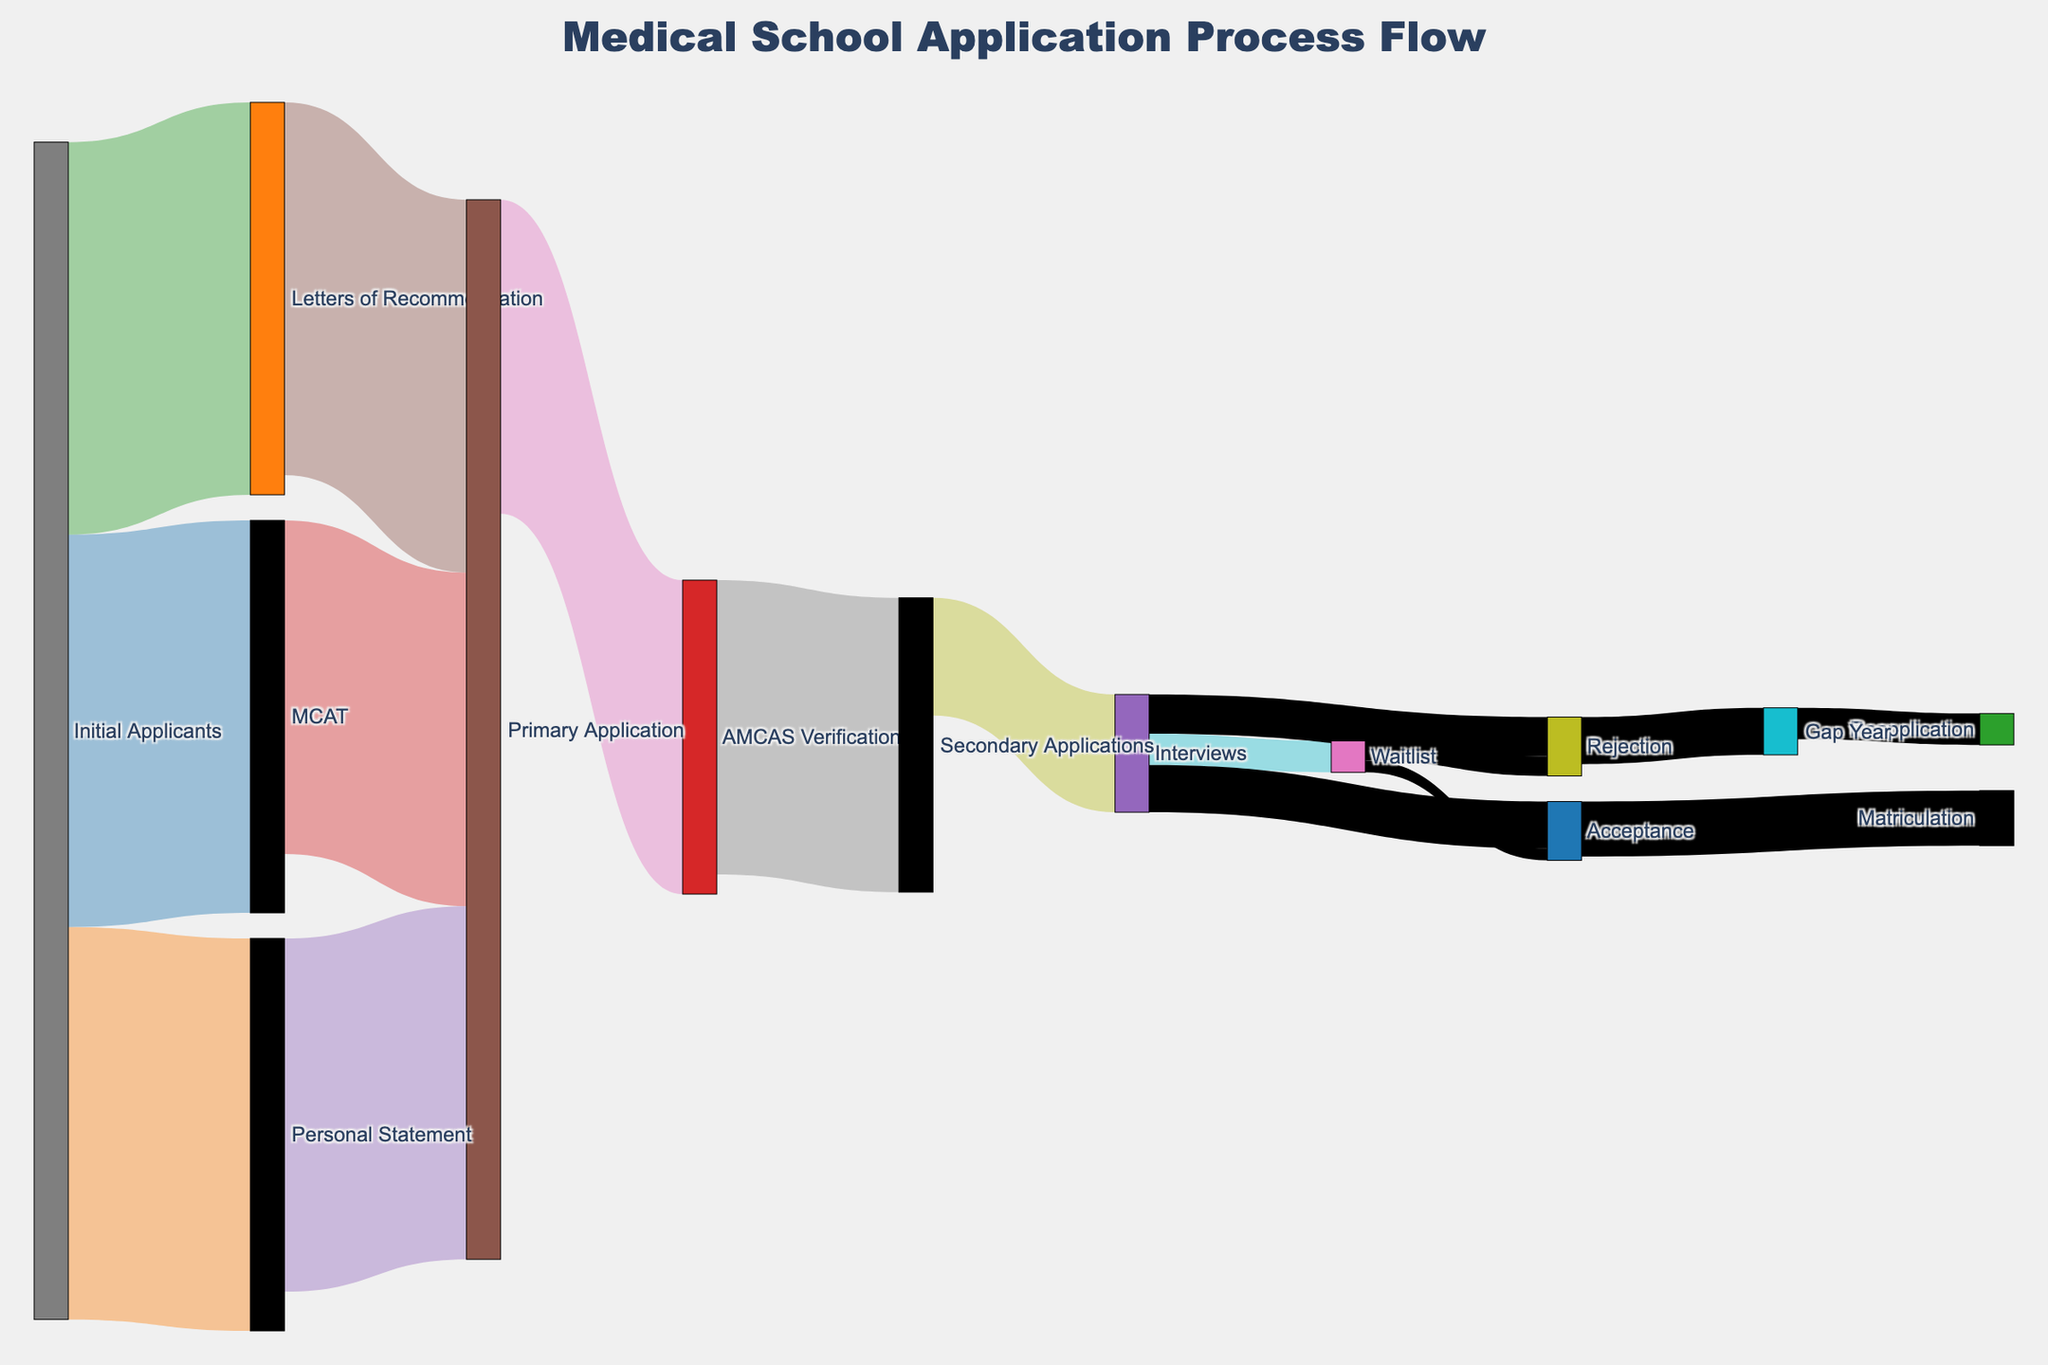What is the title of the Sankey diagram? The title is located at the top of the figure and indicates the information the diagram represents. It says "Medical School Application Process Flow."
Answer: Medical School Application Process Flow How many initial applicants proceed to take the MCAT? From the initial applicants, the source node labeled "Initial Applicants" flows directly to the MCAT, with the value representing the number of applicants. The value is 10,000.
Answer: 10,000 Which part of the process has the smallest number of applicants moving forward after AMCAS Verification? After AMCAS Verification, the number of applicants splits into secondary applications. Checking the values for these, Interviews is one of the targets, showing that it has 3,000 applicants moving forward.
Answer: Interviews What is the sum of applicants reaching the secondary applications stage? To figure this out, look at the values flowing into Secondary Applications from AMCAS Verification. The value reaching Secondary Applications is 7,500.
Answer: 7,500 How many applicants are accepted after being on the waitlist? The flow from Waitlist to Acceptance shows the value, which indicates 300 applicants are accepted from the waitlist.
Answer: 300 What is the total number of applicants who get rejected in the secondary applications stage? We need to sum the applicants rejected directly after interviews and the applicants rejected after being on the waitlist. These values are 1,000 and 500 respectively, making a total of 1,500.
Answer: 1,500 Which stage directly follows AMCAS Verification? The Sankey diagram shows the flow from AMCAS Verification directly to Secondary Applications.
Answer: Secondary Applications Compare the number of applicants who took the MCAT to those who submitted Letters of Recommendation. Which is higher? The values flowing from Initial Applicants to MCAT and Letters of Recommendation are given. Both flows show a value of 10,000. Hence, they are equal.
Answer: They are equal How many applicants ultimately matriculate? The final stage, Matriculation, is reached by flows from Acceptance. The value flowing into Matriculation is given as 1,400.
Answer: 1,400 What is the number of applicants taking a gap year after rejection from interviews? The rejection path from Interviews to Gap Year shows the value as 1,200 applicants.
Answer: 1,200 